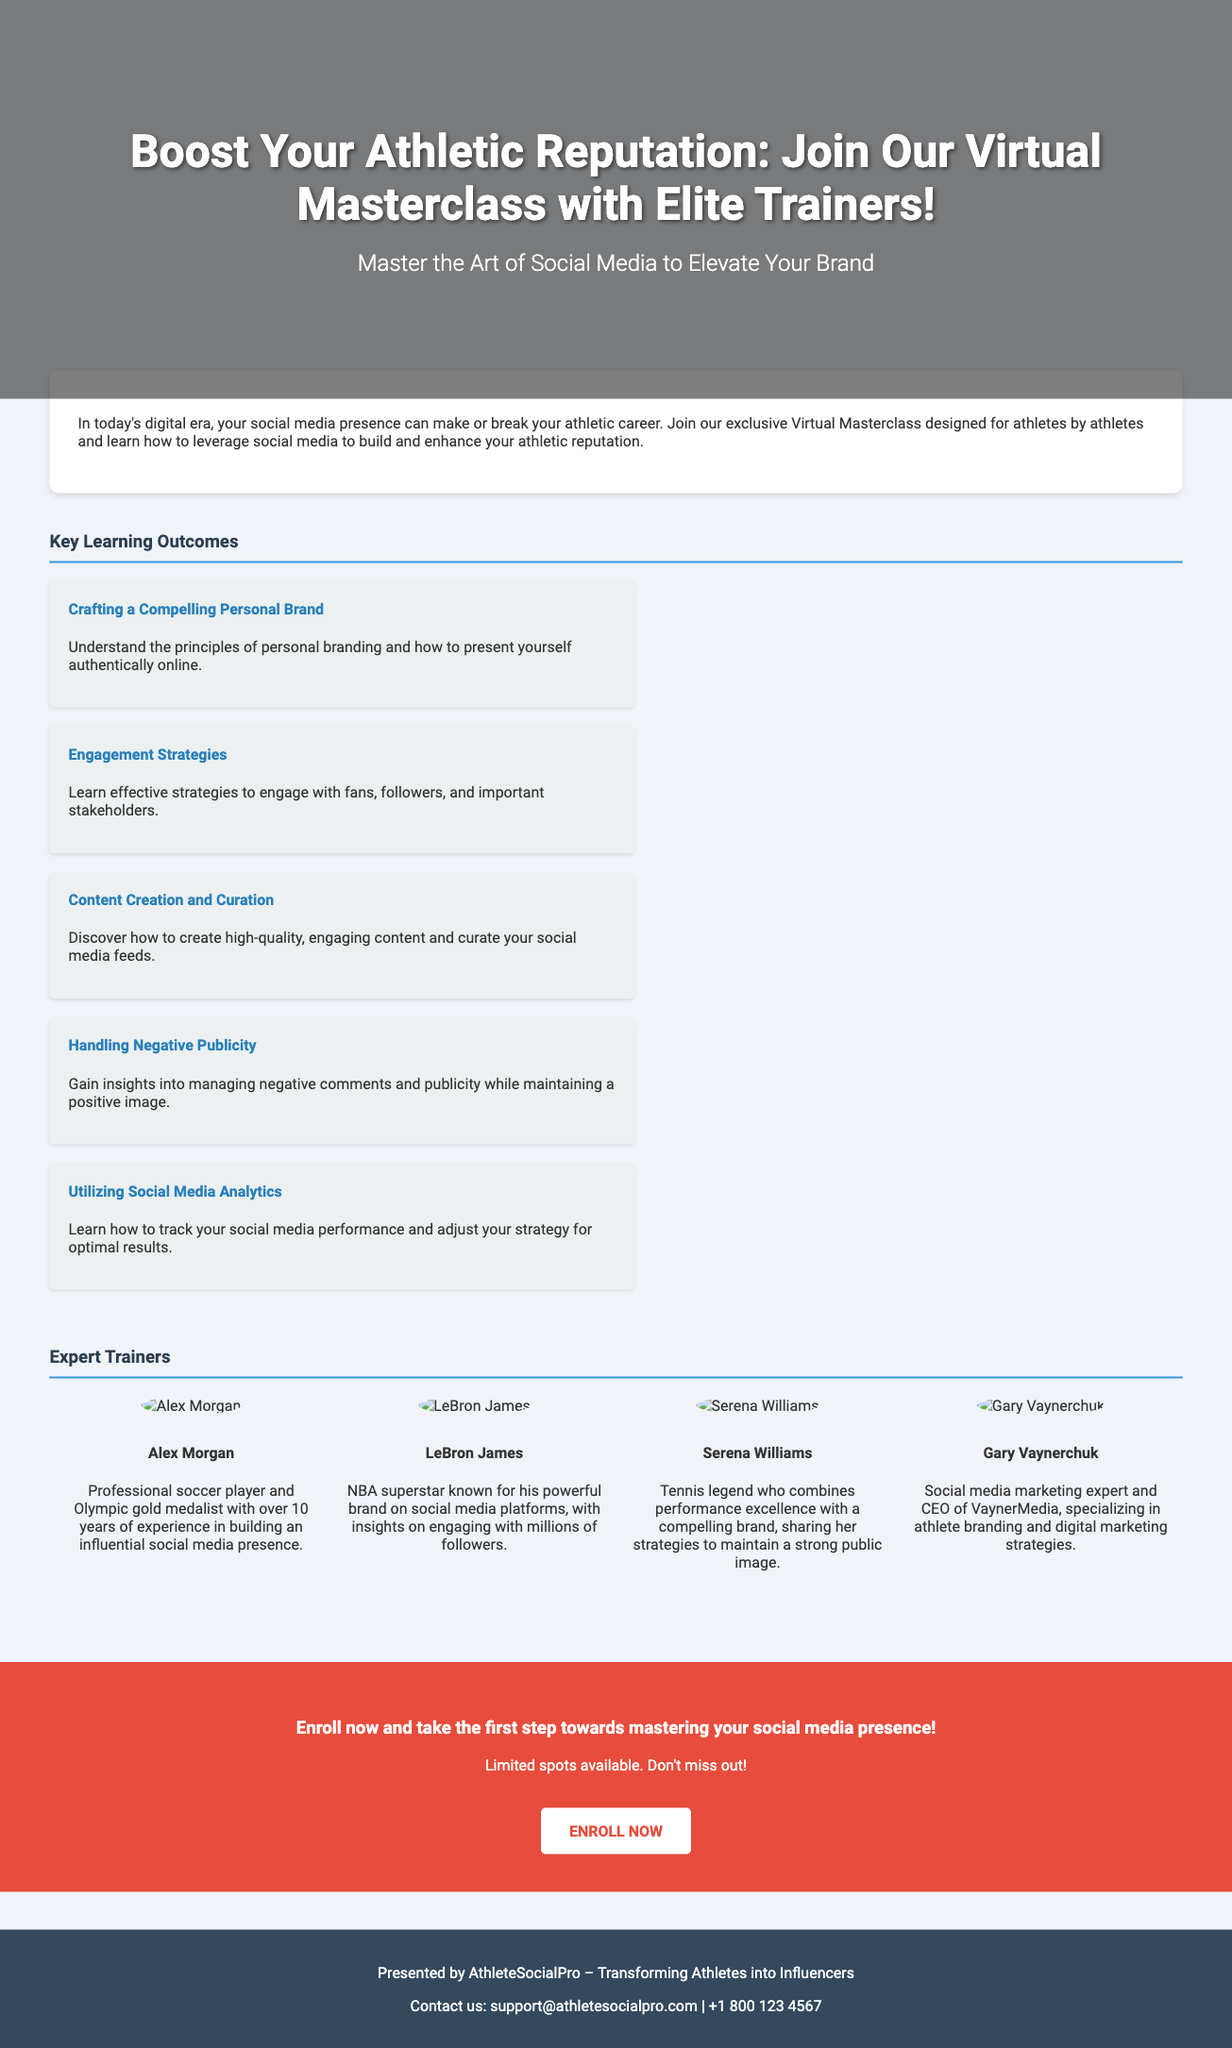What is the title of the masterclass? The title of the masterclass is prominently displayed at the top of the document.
Answer: Boost Your Athletic Reputation: Join Our Virtual Masterclass with Elite Trainers! Who is one of the expert trainers? The document lists several expert trainers, and the question asks for any one of them.
Answer: Alex Morgan What is one of the key learning outcomes mentioned? The document outlines several outcomes, and the question asks for any of these.
Answer: Crafting a Compelling Personal Brand How many trainers are featured in the document? The document features a specific number of trainers displayed in the trainer section.
Answer: Four What is the call-to-action in the advertisement? The advertisement encourages readers to take a specific action at the end of the document.
Answer: ENROLL NOW What is the background color of the document? The background color is described in the CSS part of the document's styling.
Answer: #f0f4f8 What is the main focus of the masterclass? This question combines information about the purpose stated in the document.
Answer: Leveraging social media to build and enhance your athletic reputation What company is presenting the advertisement? The footer of the document indicates which organization is behind the masterclass.
Answer: AthleteSocialPro 